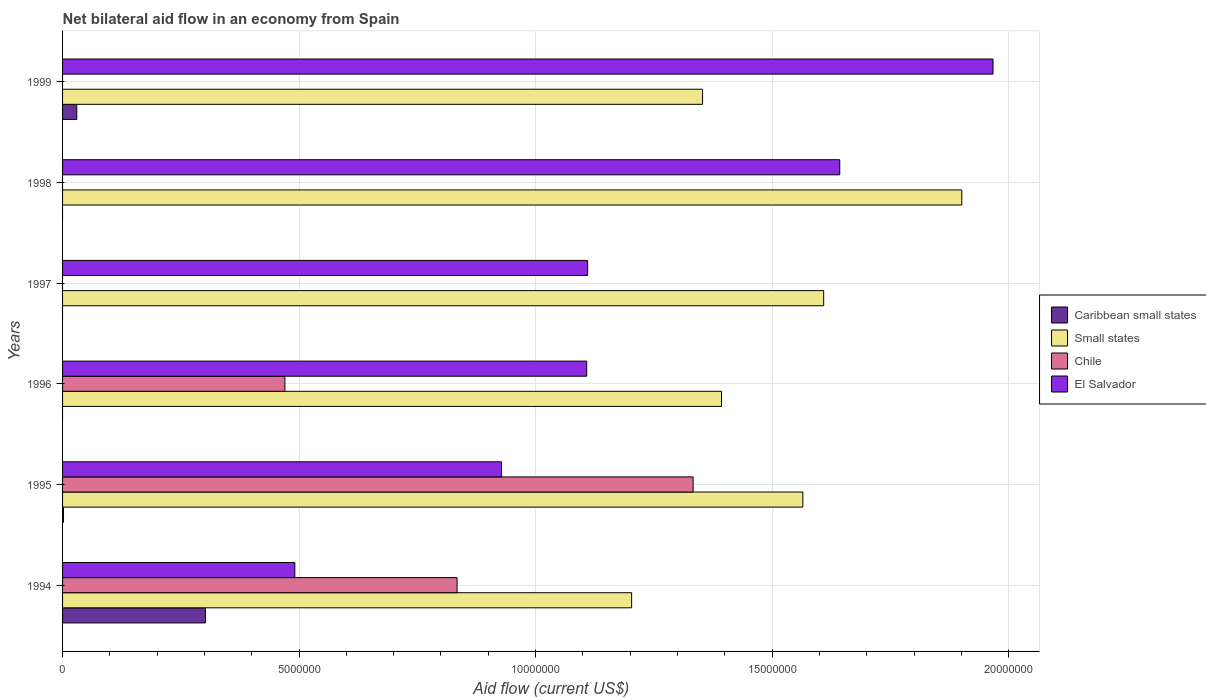How many bars are there on the 3rd tick from the top?
Offer a terse response. 2. In how many cases, is the number of bars for a given year not equal to the number of legend labels?
Your answer should be compact. 4. What is the net bilateral aid flow in Caribbean small states in 1995?
Your answer should be very brief. 2.00e+04. Across all years, what is the maximum net bilateral aid flow in El Salvador?
Offer a terse response. 1.97e+07. Across all years, what is the minimum net bilateral aid flow in El Salvador?
Offer a terse response. 4.91e+06. In which year was the net bilateral aid flow in Small states maximum?
Ensure brevity in your answer.  1998. What is the total net bilateral aid flow in Caribbean small states in the graph?
Give a very brief answer. 3.34e+06. What is the difference between the net bilateral aid flow in El Salvador in 1996 and that in 1998?
Offer a terse response. -5.35e+06. What is the difference between the net bilateral aid flow in El Salvador in 1994 and the net bilateral aid flow in Small states in 1995?
Your answer should be compact. -1.07e+07. What is the average net bilateral aid flow in Chile per year?
Offer a very short reply. 4.40e+06. In the year 1999, what is the difference between the net bilateral aid flow in Caribbean small states and net bilateral aid flow in El Salvador?
Provide a succinct answer. -1.94e+07. What is the ratio of the net bilateral aid flow in Small states in 1996 to that in 1997?
Offer a terse response. 0.87. What is the difference between the highest and the second highest net bilateral aid flow in Chile?
Offer a very short reply. 4.99e+06. What is the difference between the highest and the lowest net bilateral aid flow in Chile?
Provide a short and direct response. 1.33e+07. In how many years, is the net bilateral aid flow in Caribbean small states greater than the average net bilateral aid flow in Caribbean small states taken over all years?
Your response must be concise. 1. Is the sum of the net bilateral aid flow in Caribbean small states in 1994 and 1999 greater than the maximum net bilateral aid flow in Chile across all years?
Provide a succinct answer. No. How many bars are there?
Provide a succinct answer. 18. Are all the bars in the graph horizontal?
Offer a very short reply. Yes. What is the difference between two consecutive major ticks on the X-axis?
Offer a very short reply. 5.00e+06. Are the values on the major ticks of X-axis written in scientific E-notation?
Offer a very short reply. No. Does the graph contain grids?
Offer a terse response. Yes. Where does the legend appear in the graph?
Give a very brief answer. Center right. How are the legend labels stacked?
Offer a very short reply. Vertical. What is the title of the graph?
Provide a short and direct response. Net bilateral aid flow in an economy from Spain. What is the label or title of the X-axis?
Give a very brief answer. Aid flow (current US$). What is the Aid flow (current US$) of Caribbean small states in 1994?
Keep it short and to the point. 3.02e+06. What is the Aid flow (current US$) of Small states in 1994?
Your answer should be very brief. 1.20e+07. What is the Aid flow (current US$) of Chile in 1994?
Your answer should be compact. 8.34e+06. What is the Aid flow (current US$) of El Salvador in 1994?
Provide a succinct answer. 4.91e+06. What is the Aid flow (current US$) of Small states in 1995?
Provide a short and direct response. 1.56e+07. What is the Aid flow (current US$) of Chile in 1995?
Your answer should be compact. 1.33e+07. What is the Aid flow (current US$) in El Salvador in 1995?
Make the answer very short. 9.28e+06. What is the Aid flow (current US$) in Small states in 1996?
Offer a very short reply. 1.39e+07. What is the Aid flow (current US$) of Chile in 1996?
Offer a terse response. 4.70e+06. What is the Aid flow (current US$) of El Salvador in 1996?
Offer a very short reply. 1.11e+07. What is the Aid flow (current US$) in Small states in 1997?
Provide a succinct answer. 1.61e+07. What is the Aid flow (current US$) in Chile in 1997?
Your answer should be very brief. 0. What is the Aid flow (current US$) of El Salvador in 1997?
Your response must be concise. 1.11e+07. What is the Aid flow (current US$) in Small states in 1998?
Provide a short and direct response. 1.90e+07. What is the Aid flow (current US$) in Chile in 1998?
Provide a succinct answer. 0. What is the Aid flow (current US$) of El Salvador in 1998?
Your answer should be compact. 1.64e+07. What is the Aid flow (current US$) of Small states in 1999?
Provide a short and direct response. 1.35e+07. What is the Aid flow (current US$) in El Salvador in 1999?
Provide a succinct answer. 1.97e+07. Across all years, what is the maximum Aid flow (current US$) of Caribbean small states?
Offer a very short reply. 3.02e+06. Across all years, what is the maximum Aid flow (current US$) in Small states?
Offer a terse response. 1.90e+07. Across all years, what is the maximum Aid flow (current US$) of Chile?
Keep it short and to the point. 1.33e+07. Across all years, what is the maximum Aid flow (current US$) of El Salvador?
Your answer should be compact. 1.97e+07. Across all years, what is the minimum Aid flow (current US$) in Small states?
Make the answer very short. 1.20e+07. Across all years, what is the minimum Aid flow (current US$) of Chile?
Give a very brief answer. 0. Across all years, what is the minimum Aid flow (current US$) of El Salvador?
Provide a succinct answer. 4.91e+06. What is the total Aid flow (current US$) in Caribbean small states in the graph?
Your answer should be very brief. 3.34e+06. What is the total Aid flow (current US$) in Small states in the graph?
Keep it short and to the point. 9.02e+07. What is the total Aid flow (current US$) in Chile in the graph?
Keep it short and to the point. 2.64e+07. What is the total Aid flow (current US$) in El Salvador in the graph?
Your answer should be compact. 7.25e+07. What is the difference between the Aid flow (current US$) of Small states in 1994 and that in 1995?
Provide a succinct answer. -3.62e+06. What is the difference between the Aid flow (current US$) in Chile in 1994 and that in 1995?
Provide a short and direct response. -4.99e+06. What is the difference between the Aid flow (current US$) of El Salvador in 1994 and that in 1995?
Offer a terse response. -4.37e+06. What is the difference between the Aid flow (current US$) in Small states in 1994 and that in 1996?
Keep it short and to the point. -1.90e+06. What is the difference between the Aid flow (current US$) of Chile in 1994 and that in 1996?
Provide a short and direct response. 3.64e+06. What is the difference between the Aid flow (current US$) of El Salvador in 1994 and that in 1996?
Ensure brevity in your answer.  -6.17e+06. What is the difference between the Aid flow (current US$) of Small states in 1994 and that in 1997?
Provide a short and direct response. -4.06e+06. What is the difference between the Aid flow (current US$) in El Salvador in 1994 and that in 1997?
Provide a short and direct response. -6.19e+06. What is the difference between the Aid flow (current US$) in Small states in 1994 and that in 1998?
Ensure brevity in your answer.  -6.98e+06. What is the difference between the Aid flow (current US$) in El Salvador in 1994 and that in 1998?
Your answer should be compact. -1.15e+07. What is the difference between the Aid flow (current US$) of Caribbean small states in 1994 and that in 1999?
Give a very brief answer. 2.72e+06. What is the difference between the Aid flow (current US$) in Small states in 1994 and that in 1999?
Your answer should be very brief. -1.50e+06. What is the difference between the Aid flow (current US$) in El Salvador in 1994 and that in 1999?
Keep it short and to the point. -1.48e+07. What is the difference between the Aid flow (current US$) in Small states in 1995 and that in 1996?
Make the answer very short. 1.72e+06. What is the difference between the Aid flow (current US$) of Chile in 1995 and that in 1996?
Your response must be concise. 8.63e+06. What is the difference between the Aid flow (current US$) in El Salvador in 1995 and that in 1996?
Offer a terse response. -1.80e+06. What is the difference between the Aid flow (current US$) in Small states in 1995 and that in 1997?
Give a very brief answer. -4.40e+05. What is the difference between the Aid flow (current US$) in El Salvador in 1995 and that in 1997?
Make the answer very short. -1.82e+06. What is the difference between the Aid flow (current US$) of Small states in 1995 and that in 1998?
Your answer should be compact. -3.36e+06. What is the difference between the Aid flow (current US$) in El Salvador in 1995 and that in 1998?
Offer a very short reply. -7.15e+06. What is the difference between the Aid flow (current US$) of Caribbean small states in 1995 and that in 1999?
Offer a very short reply. -2.80e+05. What is the difference between the Aid flow (current US$) in Small states in 1995 and that in 1999?
Your answer should be very brief. 2.12e+06. What is the difference between the Aid flow (current US$) in El Salvador in 1995 and that in 1999?
Offer a very short reply. -1.04e+07. What is the difference between the Aid flow (current US$) in Small states in 1996 and that in 1997?
Offer a very short reply. -2.16e+06. What is the difference between the Aid flow (current US$) in Small states in 1996 and that in 1998?
Make the answer very short. -5.08e+06. What is the difference between the Aid flow (current US$) of El Salvador in 1996 and that in 1998?
Your answer should be compact. -5.35e+06. What is the difference between the Aid flow (current US$) in El Salvador in 1996 and that in 1999?
Give a very brief answer. -8.59e+06. What is the difference between the Aid flow (current US$) of Small states in 1997 and that in 1998?
Give a very brief answer. -2.92e+06. What is the difference between the Aid flow (current US$) in El Salvador in 1997 and that in 1998?
Your response must be concise. -5.33e+06. What is the difference between the Aid flow (current US$) in Small states in 1997 and that in 1999?
Your answer should be very brief. 2.56e+06. What is the difference between the Aid flow (current US$) of El Salvador in 1997 and that in 1999?
Your answer should be very brief. -8.57e+06. What is the difference between the Aid flow (current US$) of Small states in 1998 and that in 1999?
Your answer should be very brief. 5.48e+06. What is the difference between the Aid flow (current US$) in El Salvador in 1998 and that in 1999?
Give a very brief answer. -3.24e+06. What is the difference between the Aid flow (current US$) of Caribbean small states in 1994 and the Aid flow (current US$) of Small states in 1995?
Your response must be concise. -1.26e+07. What is the difference between the Aid flow (current US$) in Caribbean small states in 1994 and the Aid flow (current US$) in Chile in 1995?
Keep it short and to the point. -1.03e+07. What is the difference between the Aid flow (current US$) of Caribbean small states in 1994 and the Aid flow (current US$) of El Salvador in 1995?
Keep it short and to the point. -6.26e+06. What is the difference between the Aid flow (current US$) of Small states in 1994 and the Aid flow (current US$) of Chile in 1995?
Keep it short and to the point. -1.30e+06. What is the difference between the Aid flow (current US$) in Small states in 1994 and the Aid flow (current US$) in El Salvador in 1995?
Your response must be concise. 2.75e+06. What is the difference between the Aid flow (current US$) of Chile in 1994 and the Aid flow (current US$) of El Salvador in 1995?
Offer a very short reply. -9.40e+05. What is the difference between the Aid flow (current US$) in Caribbean small states in 1994 and the Aid flow (current US$) in Small states in 1996?
Offer a very short reply. -1.09e+07. What is the difference between the Aid flow (current US$) in Caribbean small states in 1994 and the Aid flow (current US$) in Chile in 1996?
Your response must be concise. -1.68e+06. What is the difference between the Aid flow (current US$) of Caribbean small states in 1994 and the Aid flow (current US$) of El Salvador in 1996?
Offer a terse response. -8.06e+06. What is the difference between the Aid flow (current US$) in Small states in 1994 and the Aid flow (current US$) in Chile in 1996?
Ensure brevity in your answer.  7.33e+06. What is the difference between the Aid flow (current US$) of Small states in 1994 and the Aid flow (current US$) of El Salvador in 1996?
Make the answer very short. 9.50e+05. What is the difference between the Aid flow (current US$) in Chile in 1994 and the Aid flow (current US$) in El Salvador in 1996?
Give a very brief answer. -2.74e+06. What is the difference between the Aid flow (current US$) of Caribbean small states in 1994 and the Aid flow (current US$) of Small states in 1997?
Provide a succinct answer. -1.31e+07. What is the difference between the Aid flow (current US$) in Caribbean small states in 1994 and the Aid flow (current US$) in El Salvador in 1997?
Your answer should be very brief. -8.08e+06. What is the difference between the Aid flow (current US$) in Small states in 1994 and the Aid flow (current US$) in El Salvador in 1997?
Keep it short and to the point. 9.30e+05. What is the difference between the Aid flow (current US$) of Chile in 1994 and the Aid flow (current US$) of El Salvador in 1997?
Give a very brief answer. -2.76e+06. What is the difference between the Aid flow (current US$) in Caribbean small states in 1994 and the Aid flow (current US$) in Small states in 1998?
Your answer should be compact. -1.60e+07. What is the difference between the Aid flow (current US$) of Caribbean small states in 1994 and the Aid flow (current US$) of El Salvador in 1998?
Offer a terse response. -1.34e+07. What is the difference between the Aid flow (current US$) of Small states in 1994 and the Aid flow (current US$) of El Salvador in 1998?
Provide a short and direct response. -4.40e+06. What is the difference between the Aid flow (current US$) in Chile in 1994 and the Aid flow (current US$) in El Salvador in 1998?
Your response must be concise. -8.09e+06. What is the difference between the Aid flow (current US$) of Caribbean small states in 1994 and the Aid flow (current US$) of Small states in 1999?
Give a very brief answer. -1.05e+07. What is the difference between the Aid flow (current US$) in Caribbean small states in 1994 and the Aid flow (current US$) in El Salvador in 1999?
Offer a very short reply. -1.66e+07. What is the difference between the Aid flow (current US$) of Small states in 1994 and the Aid flow (current US$) of El Salvador in 1999?
Ensure brevity in your answer.  -7.64e+06. What is the difference between the Aid flow (current US$) of Chile in 1994 and the Aid flow (current US$) of El Salvador in 1999?
Your answer should be very brief. -1.13e+07. What is the difference between the Aid flow (current US$) in Caribbean small states in 1995 and the Aid flow (current US$) in Small states in 1996?
Make the answer very short. -1.39e+07. What is the difference between the Aid flow (current US$) of Caribbean small states in 1995 and the Aid flow (current US$) of Chile in 1996?
Your answer should be very brief. -4.68e+06. What is the difference between the Aid flow (current US$) in Caribbean small states in 1995 and the Aid flow (current US$) in El Salvador in 1996?
Offer a very short reply. -1.11e+07. What is the difference between the Aid flow (current US$) of Small states in 1995 and the Aid flow (current US$) of Chile in 1996?
Provide a succinct answer. 1.10e+07. What is the difference between the Aid flow (current US$) in Small states in 1995 and the Aid flow (current US$) in El Salvador in 1996?
Your answer should be very brief. 4.57e+06. What is the difference between the Aid flow (current US$) in Chile in 1995 and the Aid flow (current US$) in El Salvador in 1996?
Your answer should be compact. 2.25e+06. What is the difference between the Aid flow (current US$) of Caribbean small states in 1995 and the Aid flow (current US$) of Small states in 1997?
Provide a succinct answer. -1.61e+07. What is the difference between the Aid flow (current US$) in Caribbean small states in 1995 and the Aid flow (current US$) in El Salvador in 1997?
Your response must be concise. -1.11e+07. What is the difference between the Aid flow (current US$) in Small states in 1995 and the Aid flow (current US$) in El Salvador in 1997?
Your response must be concise. 4.55e+06. What is the difference between the Aid flow (current US$) in Chile in 1995 and the Aid flow (current US$) in El Salvador in 1997?
Your answer should be very brief. 2.23e+06. What is the difference between the Aid flow (current US$) of Caribbean small states in 1995 and the Aid flow (current US$) of Small states in 1998?
Ensure brevity in your answer.  -1.90e+07. What is the difference between the Aid flow (current US$) of Caribbean small states in 1995 and the Aid flow (current US$) of El Salvador in 1998?
Your response must be concise. -1.64e+07. What is the difference between the Aid flow (current US$) of Small states in 1995 and the Aid flow (current US$) of El Salvador in 1998?
Provide a short and direct response. -7.80e+05. What is the difference between the Aid flow (current US$) in Chile in 1995 and the Aid flow (current US$) in El Salvador in 1998?
Give a very brief answer. -3.10e+06. What is the difference between the Aid flow (current US$) in Caribbean small states in 1995 and the Aid flow (current US$) in Small states in 1999?
Your answer should be compact. -1.35e+07. What is the difference between the Aid flow (current US$) of Caribbean small states in 1995 and the Aid flow (current US$) of El Salvador in 1999?
Your answer should be compact. -1.96e+07. What is the difference between the Aid flow (current US$) of Small states in 1995 and the Aid flow (current US$) of El Salvador in 1999?
Ensure brevity in your answer.  -4.02e+06. What is the difference between the Aid flow (current US$) of Chile in 1995 and the Aid flow (current US$) of El Salvador in 1999?
Offer a very short reply. -6.34e+06. What is the difference between the Aid flow (current US$) in Small states in 1996 and the Aid flow (current US$) in El Salvador in 1997?
Ensure brevity in your answer.  2.83e+06. What is the difference between the Aid flow (current US$) in Chile in 1996 and the Aid flow (current US$) in El Salvador in 1997?
Give a very brief answer. -6.40e+06. What is the difference between the Aid flow (current US$) of Small states in 1996 and the Aid flow (current US$) of El Salvador in 1998?
Your answer should be very brief. -2.50e+06. What is the difference between the Aid flow (current US$) in Chile in 1996 and the Aid flow (current US$) in El Salvador in 1998?
Your answer should be very brief. -1.17e+07. What is the difference between the Aid flow (current US$) in Small states in 1996 and the Aid flow (current US$) in El Salvador in 1999?
Provide a short and direct response. -5.74e+06. What is the difference between the Aid flow (current US$) of Chile in 1996 and the Aid flow (current US$) of El Salvador in 1999?
Offer a terse response. -1.50e+07. What is the difference between the Aid flow (current US$) in Small states in 1997 and the Aid flow (current US$) in El Salvador in 1998?
Provide a short and direct response. -3.40e+05. What is the difference between the Aid flow (current US$) in Small states in 1997 and the Aid flow (current US$) in El Salvador in 1999?
Keep it short and to the point. -3.58e+06. What is the difference between the Aid flow (current US$) in Small states in 1998 and the Aid flow (current US$) in El Salvador in 1999?
Ensure brevity in your answer.  -6.60e+05. What is the average Aid flow (current US$) of Caribbean small states per year?
Your response must be concise. 5.57e+05. What is the average Aid flow (current US$) in Small states per year?
Give a very brief answer. 1.50e+07. What is the average Aid flow (current US$) of Chile per year?
Your answer should be very brief. 4.40e+06. What is the average Aid flow (current US$) of El Salvador per year?
Your response must be concise. 1.21e+07. In the year 1994, what is the difference between the Aid flow (current US$) of Caribbean small states and Aid flow (current US$) of Small states?
Give a very brief answer. -9.01e+06. In the year 1994, what is the difference between the Aid flow (current US$) of Caribbean small states and Aid flow (current US$) of Chile?
Provide a succinct answer. -5.32e+06. In the year 1994, what is the difference between the Aid flow (current US$) of Caribbean small states and Aid flow (current US$) of El Salvador?
Offer a terse response. -1.89e+06. In the year 1994, what is the difference between the Aid flow (current US$) in Small states and Aid flow (current US$) in Chile?
Give a very brief answer. 3.69e+06. In the year 1994, what is the difference between the Aid flow (current US$) in Small states and Aid flow (current US$) in El Salvador?
Provide a succinct answer. 7.12e+06. In the year 1994, what is the difference between the Aid flow (current US$) of Chile and Aid flow (current US$) of El Salvador?
Ensure brevity in your answer.  3.43e+06. In the year 1995, what is the difference between the Aid flow (current US$) in Caribbean small states and Aid flow (current US$) in Small states?
Your answer should be very brief. -1.56e+07. In the year 1995, what is the difference between the Aid flow (current US$) in Caribbean small states and Aid flow (current US$) in Chile?
Your answer should be very brief. -1.33e+07. In the year 1995, what is the difference between the Aid flow (current US$) of Caribbean small states and Aid flow (current US$) of El Salvador?
Provide a short and direct response. -9.26e+06. In the year 1995, what is the difference between the Aid flow (current US$) in Small states and Aid flow (current US$) in Chile?
Your answer should be very brief. 2.32e+06. In the year 1995, what is the difference between the Aid flow (current US$) of Small states and Aid flow (current US$) of El Salvador?
Ensure brevity in your answer.  6.37e+06. In the year 1995, what is the difference between the Aid flow (current US$) in Chile and Aid flow (current US$) in El Salvador?
Ensure brevity in your answer.  4.05e+06. In the year 1996, what is the difference between the Aid flow (current US$) in Small states and Aid flow (current US$) in Chile?
Your response must be concise. 9.23e+06. In the year 1996, what is the difference between the Aid flow (current US$) of Small states and Aid flow (current US$) of El Salvador?
Your response must be concise. 2.85e+06. In the year 1996, what is the difference between the Aid flow (current US$) of Chile and Aid flow (current US$) of El Salvador?
Offer a terse response. -6.38e+06. In the year 1997, what is the difference between the Aid flow (current US$) of Small states and Aid flow (current US$) of El Salvador?
Your response must be concise. 4.99e+06. In the year 1998, what is the difference between the Aid flow (current US$) of Small states and Aid flow (current US$) of El Salvador?
Offer a terse response. 2.58e+06. In the year 1999, what is the difference between the Aid flow (current US$) of Caribbean small states and Aid flow (current US$) of Small states?
Ensure brevity in your answer.  -1.32e+07. In the year 1999, what is the difference between the Aid flow (current US$) in Caribbean small states and Aid flow (current US$) in El Salvador?
Give a very brief answer. -1.94e+07. In the year 1999, what is the difference between the Aid flow (current US$) of Small states and Aid flow (current US$) of El Salvador?
Ensure brevity in your answer.  -6.14e+06. What is the ratio of the Aid flow (current US$) in Caribbean small states in 1994 to that in 1995?
Keep it short and to the point. 151. What is the ratio of the Aid flow (current US$) in Small states in 1994 to that in 1995?
Offer a very short reply. 0.77. What is the ratio of the Aid flow (current US$) in Chile in 1994 to that in 1995?
Offer a terse response. 0.63. What is the ratio of the Aid flow (current US$) in El Salvador in 1994 to that in 1995?
Your answer should be very brief. 0.53. What is the ratio of the Aid flow (current US$) in Small states in 1994 to that in 1996?
Your answer should be very brief. 0.86. What is the ratio of the Aid flow (current US$) in Chile in 1994 to that in 1996?
Offer a terse response. 1.77. What is the ratio of the Aid flow (current US$) in El Salvador in 1994 to that in 1996?
Provide a short and direct response. 0.44. What is the ratio of the Aid flow (current US$) in Small states in 1994 to that in 1997?
Give a very brief answer. 0.75. What is the ratio of the Aid flow (current US$) of El Salvador in 1994 to that in 1997?
Give a very brief answer. 0.44. What is the ratio of the Aid flow (current US$) in Small states in 1994 to that in 1998?
Make the answer very short. 0.63. What is the ratio of the Aid flow (current US$) of El Salvador in 1994 to that in 1998?
Offer a very short reply. 0.3. What is the ratio of the Aid flow (current US$) in Caribbean small states in 1994 to that in 1999?
Provide a short and direct response. 10.07. What is the ratio of the Aid flow (current US$) in Small states in 1994 to that in 1999?
Your response must be concise. 0.89. What is the ratio of the Aid flow (current US$) in El Salvador in 1994 to that in 1999?
Your answer should be very brief. 0.25. What is the ratio of the Aid flow (current US$) of Small states in 1995 to that in 1996?
Provide a short and direct response. 1.12. What is the ratio of the Aid flow (current US$) in Chile in 1995 to that in 1996?
Provide a short and direct response. 2.84. What is the ratio of the Aid flow (current US$) of El Salvador in 1995 to that in 1996?
Make the answer very short. 0.84. What is the ratio of the Aid flow (current US$) in Small states in 1995 to that in 1997?
Keep it short and to the point. 0.97. What is the ratio of the Aid flow (current US$) of El Salvador in 1995 to that in 1997?
Your answer should be very brief. 0.84. What is the ratio of the Aid flow (current US$) of Small states in 1995 to that in 1998?
Offer a terse response. 0.82. What is the ratio of the Aid flow (current US$) of El Salvador in 1995 to that in 1998?
Offer a terse response. 0.56. What is the ratio of the Aid flow (current US$) of Caribbean small states in 1995 to that in 1999?
Provide a short and direct response. 0.07. What is the ratio of the Aid flow (current US$) of Small states in 1995 to that in 1999?
Your answer should be very brief. 1.16. What is the ratio of the Aid flow (current US$) in El Salvador in 1995 to that in 1999?
Provide a short and direct response. 0.47. What is the ratio of the Aid flow (current US$) of Small states in 1996 to that in 1997?
Make the answer very short. 0.87. What is the ratio of the Aid flow (current US$) in Small states in 1996 to that in 1998?
Your answer should be very brief. 0.73. What is the ratio of the Aid flow (current US$) in El Salvador in 1996 to that in 1998?
Offer a terse response. 0.67. What is the ratio of the Aid flow (current US$) of Small states in 1996 to that in 1999?
Give a very brief answer. 1.03. What is the ratio of the Aid flow (current US$) in El Salvador in 1996 to that in 1999?
Your response must be concise. 0.56. What is the ratio of the Aid flow (current US$) of Small states in 1997 to that in 1998?
Make the answer very short. 0.85. What is the ratio of the Aid flow (current US$) in El Salvador in 1997 to that in 1998?
Give a very brief answer. 0.68. What is the ratio of the Aid flow (current US$) in Small states in 1997 to that in 1999?
Your answer should be very brief. 1.19. What is the ratio of the Aid flow (current US$) in El Salvador in 1997 to that in 1999?
Your response must be concise. 0.56. What is the ratio of the Aid flow (current US$) in Small states in 1998 to that in 1999?
Provide a succinct answer. 1.41. What is the ratio of the Aid flow (current US$) of El Salvador in 1998 to that in 1999?
Your response must be concise. 0.84. What is the difference between the highest and the second highest Aid flow (current US$) in Caribbean small states?
Offer a terse response. 2.72e+06. What is the difference between the highest and the second highest Aid flow (current US$) in Small states?
Give a very brief answer. 2.92e+06. What is the difference between the highest and the second highest Aid flow (current US$) in Chile?
Give a very brief answer. 4.99e+06. What is the difference between the highest and the second highest Aid flow (current US$) in El Salvador?
Offer a terse response. 3.24e+06. What is the difference between the highest and the lowest Aid flow (current US$) in Caribbean small states?
Ensure brevity in your answer.  3.02e+06. What is the difference between the highest and the lowest Aid flow (current US$) of Small states?
Ensure brevity in your answer.  6.98e+06. What is the difference between the highest and the lowest Aid flow (current US$) in Chile?
Provide a succinct answer. 1.33e+07. What is the difference between the highest and the lowest Aid flow (current US$) of El Salvador?
Keep it short and to the point. 1.48e+07. 